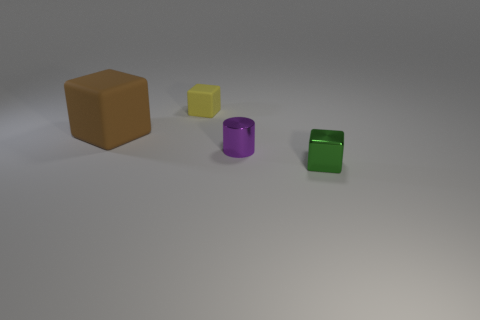Add 4 tiny rubber objects. How many objects exist? 8 Subtract all cylinders. How many objects are left? 3 Add 1 tiny yellow cylinders. How many tiny yellow cylinders exist? 1 Subtract 0 brown balls. How many objects are left? 4 Subtract all large red matte balls. Subtract all tiny cylinders. How many objects are left? 3 Add 1 tiny purple cylinders. How many tiny purple cylinders are left? 2 